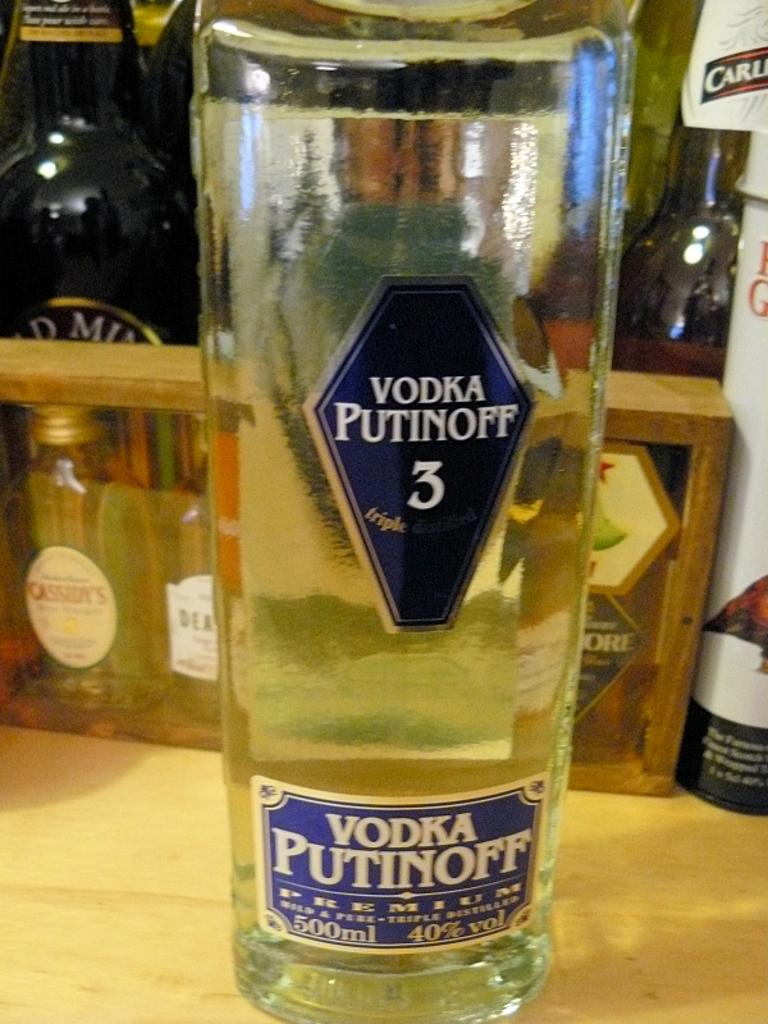What is the main object in the image? There is a vodka bottle with a label in the image. Where is the vodka bottle located? The vodka bottle is placed on a table. Can you describe any other objects visible in the image? There are bottles visible in the background of the image. What type of key is the queen holding in the image? There is no queen or key present in the image; it only features a vodka bottle with a label on a table and bottles in the background. 